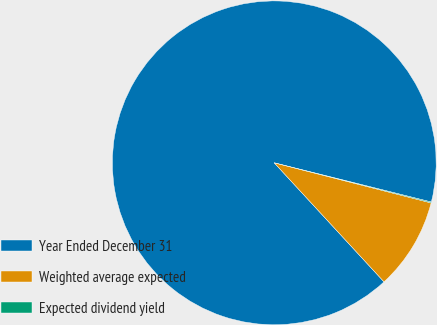Convert chart to OTSL. <chart><loc_0><loc_0><loc_500><loc_500><pie_chart><fcel>Year Ended December 31<fcel>Weighted average expected<fcel>Expected dividend yield<nl><fcel>90.75%<fcel>9.16%<fcel>0.09%<nl></chart> 